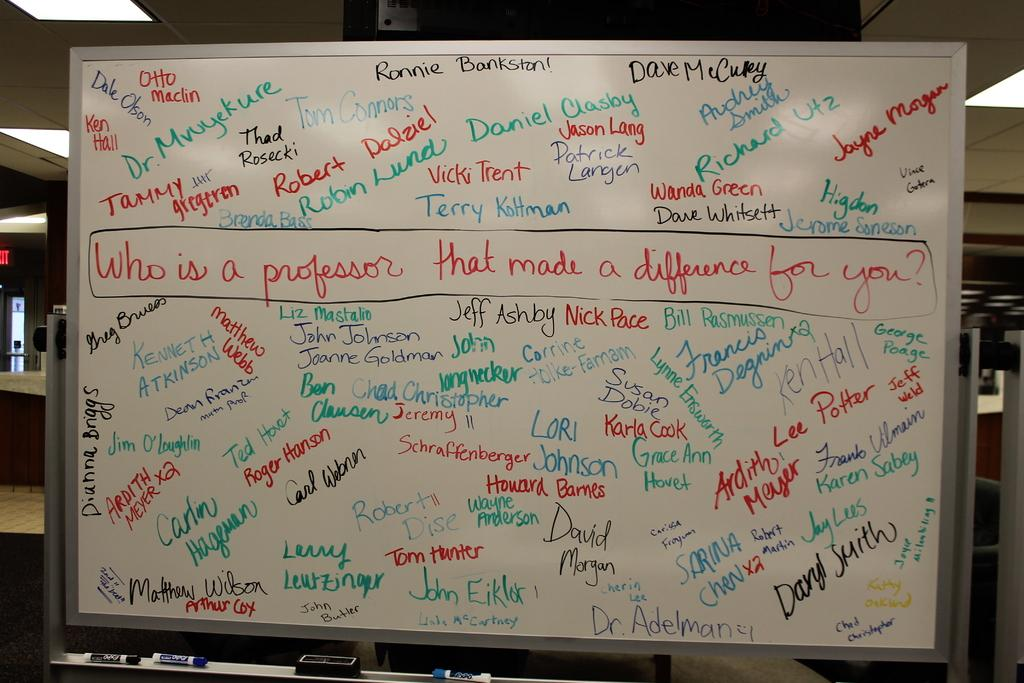<image>
Offer a succinct explanation of the picture presented. A whiteboard with names written all over it with the first being Ronnie Bankston written in black. 